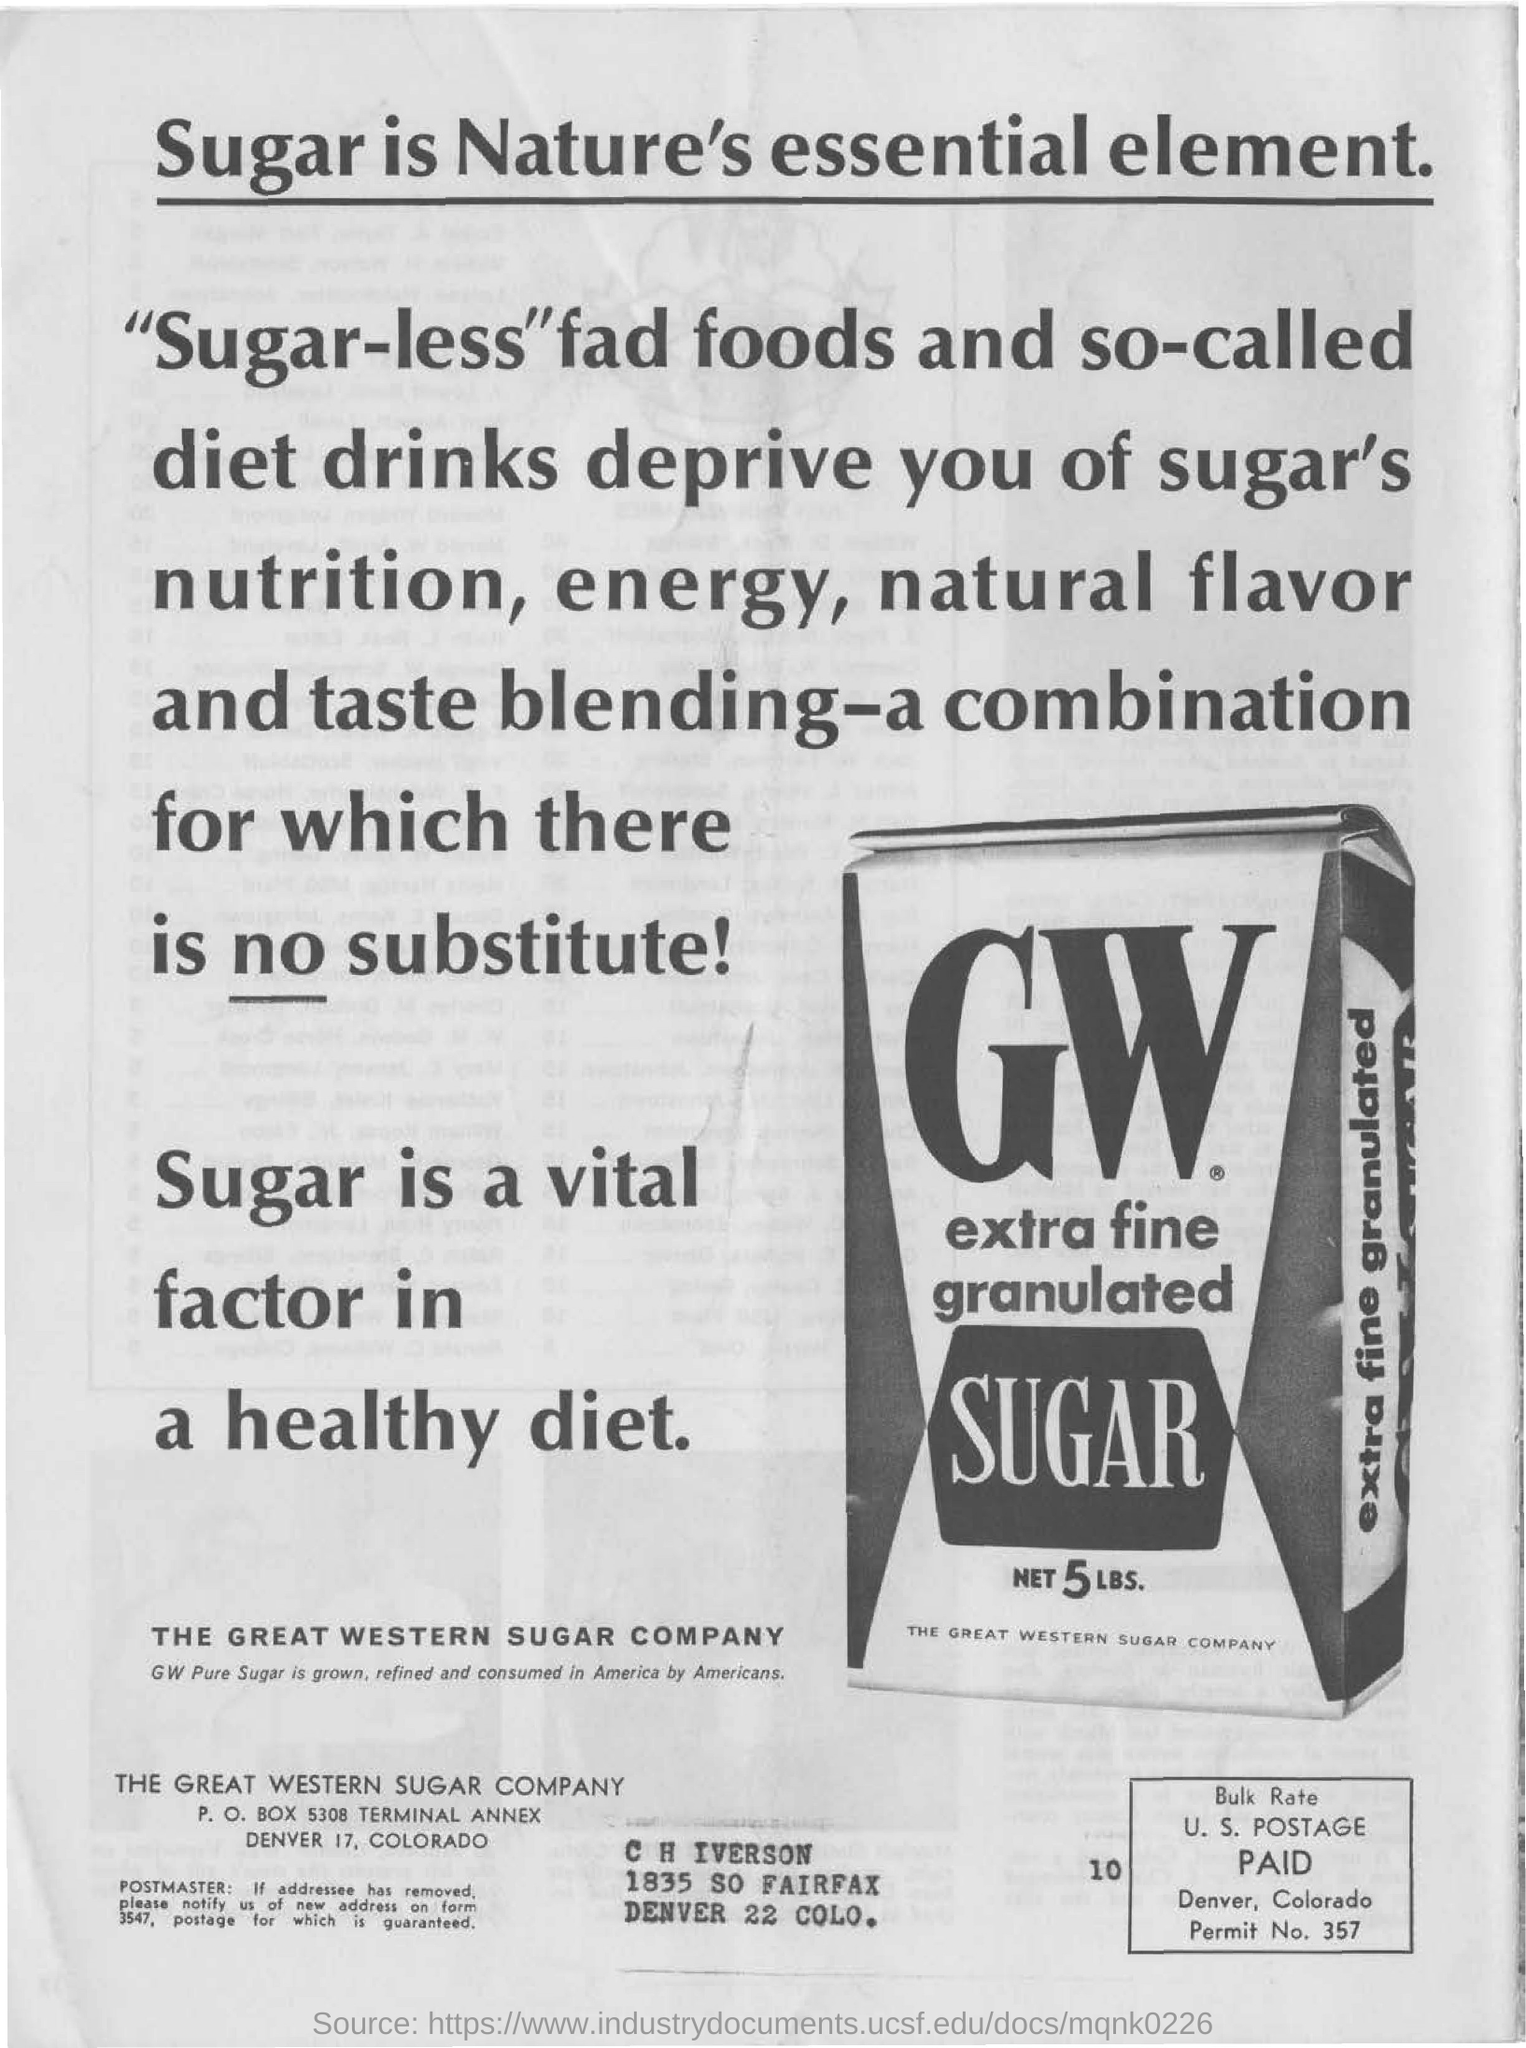What type of product is on the image?
Keep it short and to the point. Gw extra fine granulated sugar. What is the net amount of the sugar?
Make the answer very short. 5 LBS. What is name of the sugar company?
Give a very brief answer. The great western sugar company. 